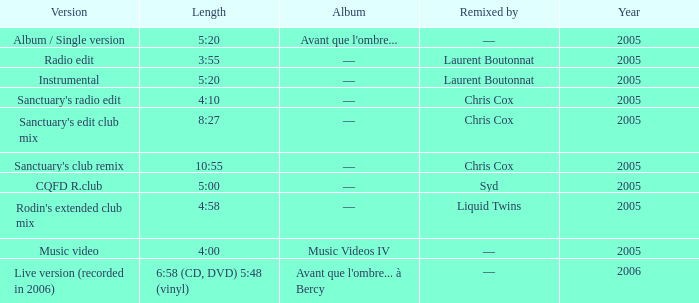What is the version displayed for the length of 5:20, and indicates remixed by —? Album / Single version. 